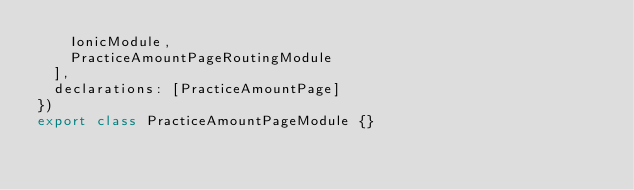Convert code to text. <code><loc_0><loc_0><loc_500><loc_500><_TypeScript_>    IonicModule,
    PracticeAmountPageRoutingModule
  ],
  declarations: [PracticeAmountPage]
})
export class PracticeAmountPageModule {}
</code> 